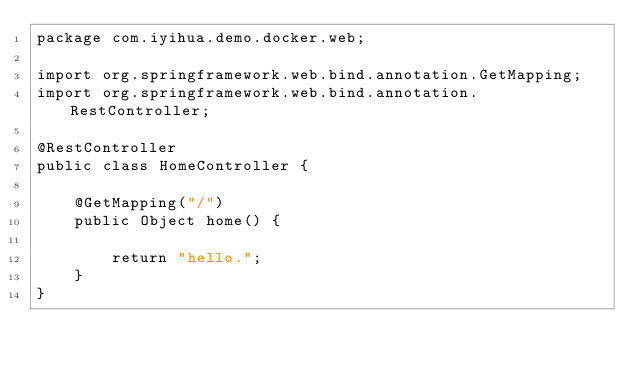<code> <loc_0><loc_0><loc_500><loc_500><_Java_>package com.iyihua.demo.docker.web;

import org.springframework.web.bind.annotation.GetMapping;
import org.springframework.web.bind.annotation.RestController;

@RestController
public class HomeController {

	@GetMapping("/")
	public Object home() {
		
		return "hello.";
	}
}
</code> 